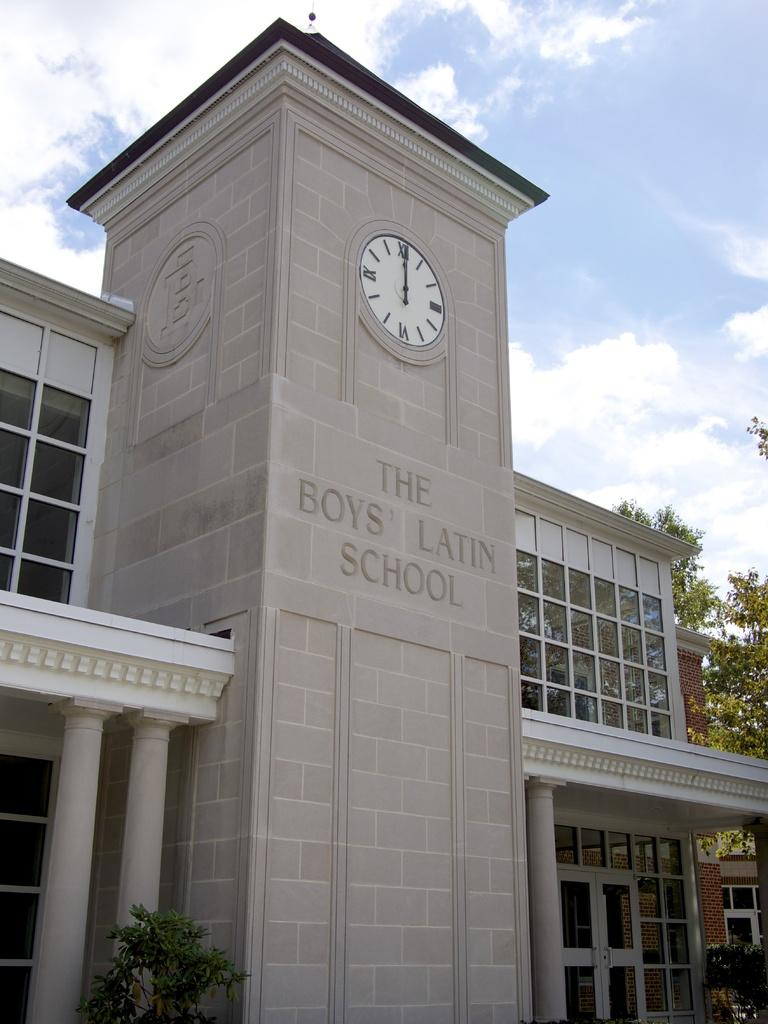Provide a one-sentence caption for the provided image. The front of The Boys' Latin School building has a clock on it. 